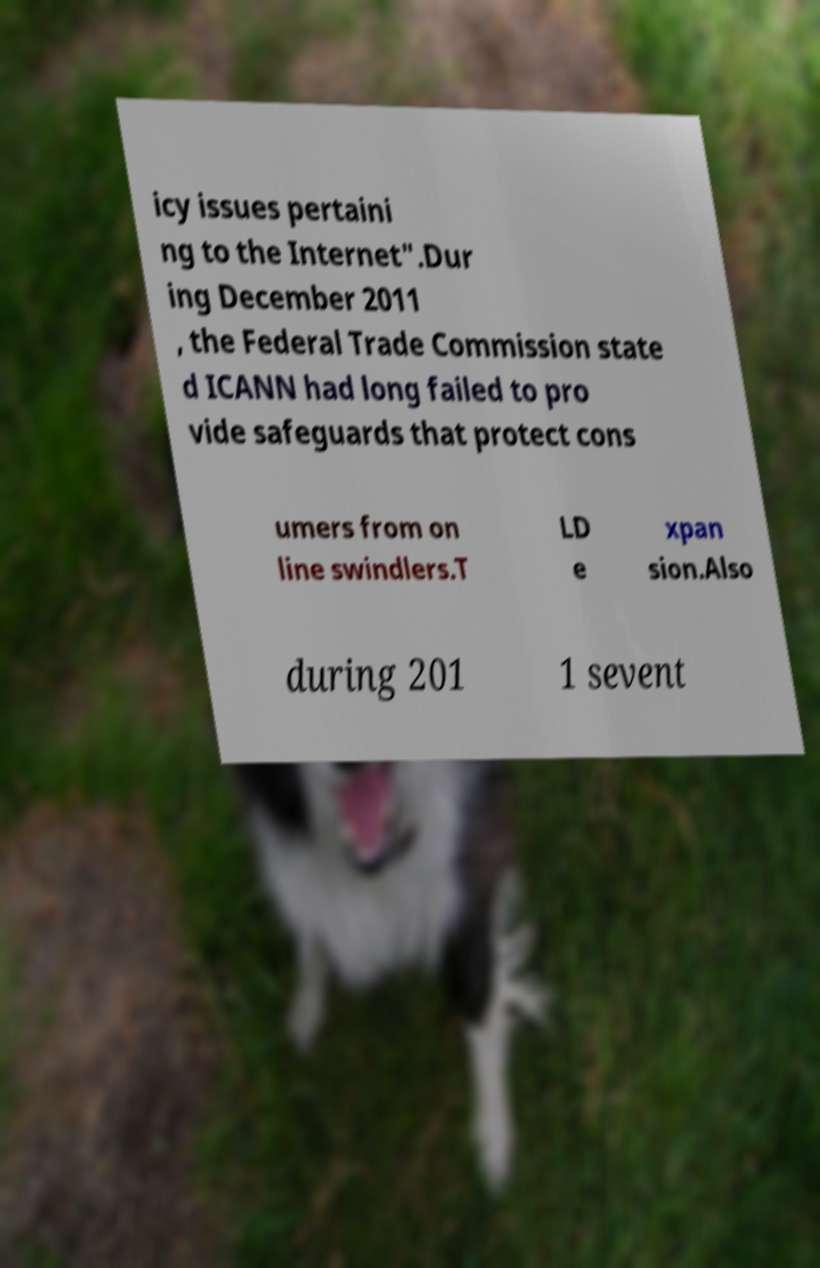Could you extract and type out the text from this image? icy issues pertaini ng to the Internet".Dur ing December 2011 , the Federal Trade Commission state d ICANN had long failed to pro vide safeguards that protect cons umers from on line swindlers.T LD e xpan sion.Also during 201 1 sevent 